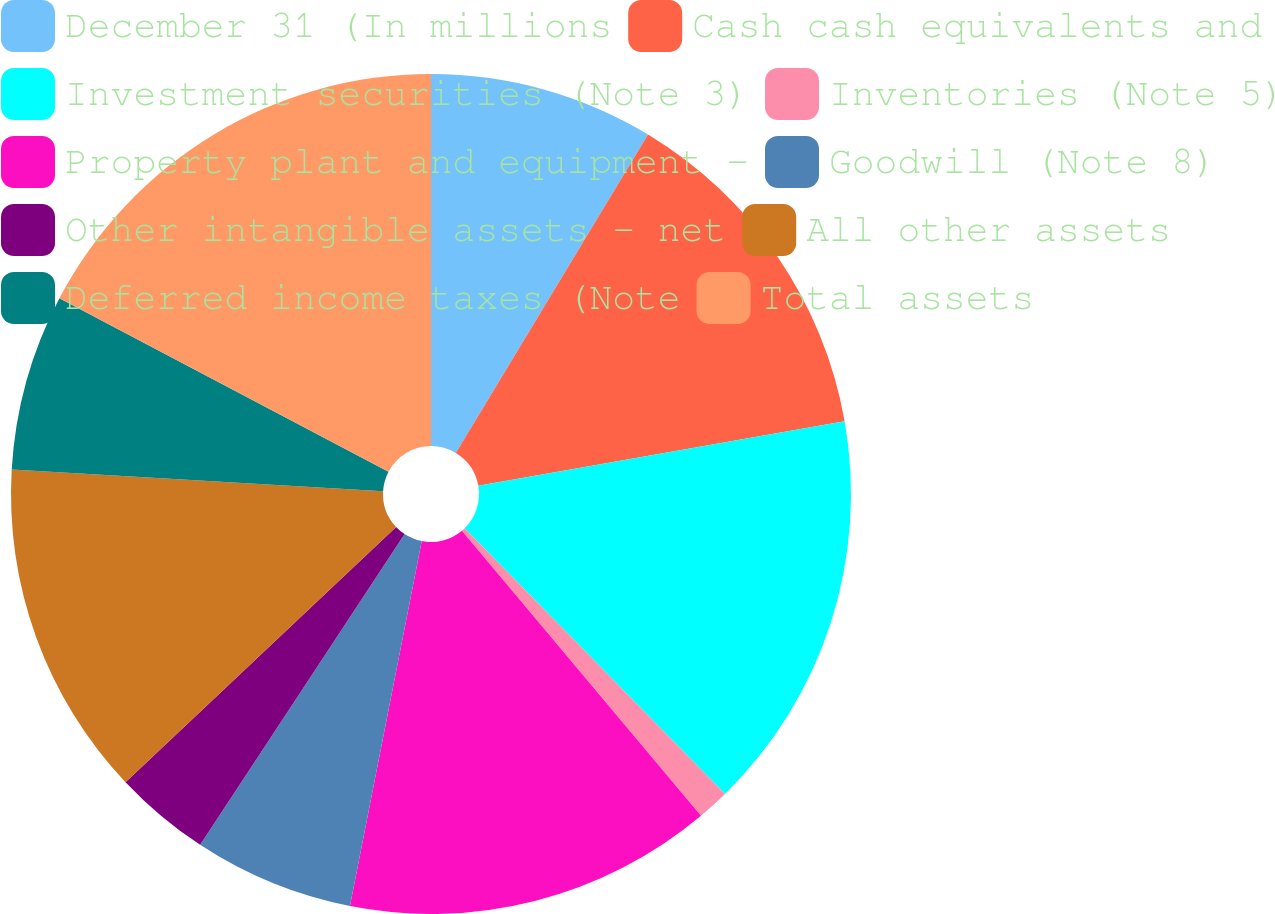Convert chart to OTSL. <chart><loc_0><loc_0><loc_500><loc_500><pie_chart><fcel>December 31 (In millions<fcel>Cash cash equivalents and<fcel>Investment securities (Note 3)<fcel>Inventories (Note 5)<fcel>Property plant and equipment -<fcel>Goodwill (Note 8)<fcel>Other intangible assets - net<fcel>All other assets<fcel>Deferred income taxes (Note<fcel>Total assets<nl><fcel>8.64%<fcel>13.58%<fcel>15.43%<fcel>1.23%<fcel>14.2%<fcel>6.17%<fcel>3.7%<fcel>12.96%<fcel>6.79%<fcel>17.28%<nl></chart> 